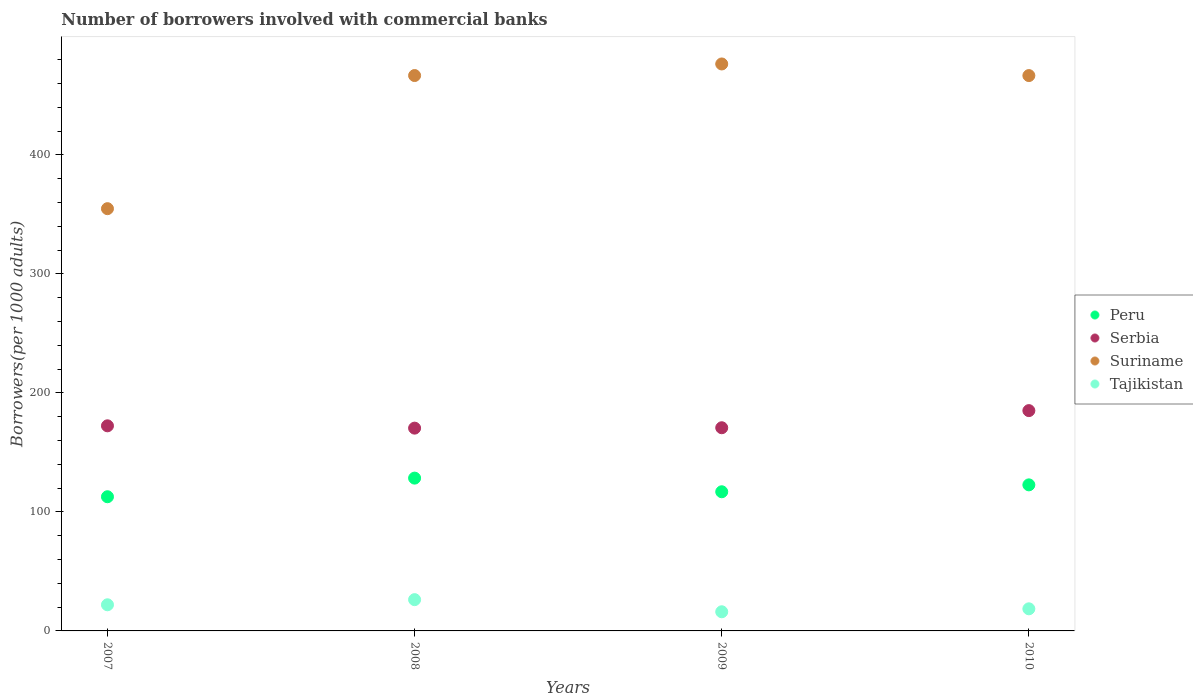What is the number of borrowers involved with commercial banks in Peru in 2008?
Give a very brief answer. 128.42. Across all years, what is the maximum number of borrowers involved with commercial banks in Serbia?
Ensure brevity in your answer.  185.15. Across all years, what is the minimum number of borrowers involved with commercial banks in Suriname?
Provide a succinct answer. 354.87. What is the total number of borrowers involved with commercial banks in Suriname in the graph?
Provide a succinct answer. 1764.83. What is the difference between the number of borrowers involved with commercial banks in Serbia in 2007 and that in 2010?
Ensure brevity in your answer.  -12.78. What is the difference between the number of borrowers involved with commercial banks in Serbia in 2009 and the number of borrowers involved with commercial banks in Tajikistan in 2010?
Provide a short and direct response. 152.17. What is the average number of borrowers involved with commercial banks in Serbia per year?
Offer a terse response. 174.68. In the year 2007, what is the difference between the number of borrowers involved with commercial banks in Peru and number of borrowers involved with commercial banks in Tajikistan?
Make the answer very short. 90.8. What is the ratio of the number of borrowers involved with commercial banks in Tajikistan in 2007 to that in 2009?
Provide a succinct answer. 1.37. What is the difference between the highest and the second highest number of borrowers involved with commercial banks in Suriname?
Give a very brief answer. 9.73. What is the difference between the highest and the lowest number of borrowers involved with commercial banks in Tajikistan?
Your response must be concise. 10.2. Is the number of borrowers involved with commercial banks in Suriname strictly greater than the number of borrowers involved with commercial banks in Peru over the years?
Offer a terse response. Yes. How many years are there in the graph?
Your answer should be very brief. 4. What is the difference between two consecutive major ticks on the Y-axis?
Make the answer very short. 100. Does the graph contain grids?
Give a very brief answer. No. Where does the legend appear in the graph?
Your answer should be compact. Center right. What is the title of the graph?
Offer a very short reply. Number of borrowers involved with commercial banks. What is the label or title of the X-axis?
Make the answer very short. Years. What is the label or title of the Y-axis?
Your answer should be very brief. Borrowers(per 1000 adults). What is the Borrowers(per 1000 adults) in Peru in 2007?
Your answer should be compact. 112.76. What is the Borrowers(per 1000 adults) in Serbia in 2007?
Provide a succinct answer. 172.37. What is the Borrowers(per 1000 adults) of Suriname in 2007?
Provide a short and direct response. 354.87. What is the Borrowers(per 1000 adults) in Tajikistan in 2007?
Offer a very short reply. 21.97. What is the Borrowers(per 1000 adults) of Peru in 2008?
Make the answer very short. 128.42. What is the Borrowers(per 1000 adults) of Serbia in 2008?
Provide a succinct answer. 170.42. What is the Borrowers(per 1000 adults) in Suriname in 2008?
Your answer should be compact. 466.75. What is the Borrowers(per 1000 adults) in Tajikistan in 2008?
Keep it short and to the point. 26.29. What is the Borrowers(per 1000 adults) of Peru in 2009?
Keep it short and to the point. 116.95. What is the Borrowers(per 1000 adults) in Serbia in 2009?
Offer a very short reply. 170.75. What is the Borrowers(per 1000 adults) of Suriname in 2009?
Offer a very short reply. 476.48. What is the Borrowers(per 1000 adults) in Tajikistan in 2009?
Ensure brevity in your answer.  16.09. What is the Borrowers(per 1000 adults) of Peru in 2010?
Your answer should be very brief. 122.75. What is the Borrowers(per 1000 adults) in Serbia in 2010?
Provide a succinct answer. 185.15. What is the Borrowers(per 1000 adults) in Suriname in 2010?
Offer a very short reply. 466.73. What is the Borrowers(per 1000 adults) of Tajikistan in 2010?
Offer a terse response. 18.58. Across all years, what is the maximum Borrowers(per 1000 adults) in Peru?
Make the answer very short. 128.42. Across all years, what is the maximum Borrowers(per 1000 adults) of Serbia?
Provide a short and direct response. 185.15. Across all years, what is the maximum Borrowers(per 1000 adults) in Suriname?
Ensure brevity in your answer.  476.48. Across all years, what is the maximum Borrowers(per 1000 adults) in Tajikistan?
Ensure brevity in your answer.  26.29. Across all years, what is the minimum Borrowers(per 1000 adults) in Peru?
Your answer should be compact. 112.76. Across all years, what is the minimum Borrowers(per 1000 adults) in Serbia?
Provide a short and direct response. 170.42. Across all years, what is the minimum Borrowers(per 1000 adults) in Suriname?
Your answer should be compact. 354.87. Across all years, what is the minimum Borrowers(per 1000 adults) of Tajikistan?
Give a very brief answer. 16.09. What is the total Borrowers(per 1000 adults) of Peru in the graph?
Make the answer very short. 480.89. What is the total Borrowers(per 1000 adults) in Serbia in the graph?
Ensure brevity in your answer.  698.7. What is the total Borrowers(per 1000 adults) of Suriname in the graph?
Offer a very short reply. 1764.83. What is the total Borrowers(per 1000 adults) of Tajikistan in the graph?
Keep it short and to the point. 82.92. What is the difference between the Borrowers(per 1000 adults) in Peru in 2007 and that in 2008?
Give a very brief answer. -15.66. What is the difference between the Borrowers(per 1000 adults) in Serbia in 2007 and that in 2008?
Make the answer very short. 1.95. What is the difference between the Borrowers(per 1000 adults) of Suriname in 2007 and that in 2008?
Provide a succinct answer. -111.88. What is the difference between the Borrowers(per 1000 adults) in Tajikistan in 2007 and that in 2008?
Your answer should be very brief. -4.32. What is the difference between the Borrowers(per 1000 adults) in Peru in 2007 and that in 2009?
Your answer should be compact. -4.19. What is the difference between the Borrowers(per 1000 adults) in Serbia in 2007 and that in 2009?
Offer a very short reply. 1.62. What is the difference between the Borrowers(per 1000 adults) in Suriname in 2007 and that in 2009?
Make the answer very short. -121.61. What is the difference between the Borrowers(per 1000 adults) of Tajikistan in 2007 and that in 2009?
Your response must be concise. 5.88. What is the difference between the Borrowers(per 1000 adults) of Peru in 2007 and that in 2010?
Ensure brevity in your answer.  -9.99. What is the difference between the Borrowers(per 1000 adults) of Serbia in 2007 and that in 2010?
Keep it short and to the point. -12.78. What is the difference between the Borrowers(per 1000 adults) of Suriname in 2007 and that in 2010?
Ensure brevity in your answer.  -111.86. What is the difference between the Borrowers(per 1000 adults) of Tajikistan in 2007 and that in 2010?
Give a very brief answer. 3.39. What is the difference between the Borrowers(per 1000 adults) in Peru in 2008 and that in 2009?
Ensure brevity in your answer.  11.47. What is the difference between the Borrowers(per 1000 adults) of Serbia in 2008 and that in 2009?
Ensure brevity in your answer.  -0.33. What is the difference between the Borrowers(per 1000 adults) of Suriname in 2008 and that in 2009?
Provide a short and direct response. -9.73. What is the difference between the Borrowers(per 1000 adults) in Tajikistan in 2008 and that in 2009?
Make the answer very short. 10.2. What is the difference between the Borrowers(per 1000 adults) of Peru in 2008 and that in 2010?
Offer a terse response. 5.67. What is the difference between the Borrowers(per 1000 adults) of Serbia in 2008 and that in 2010?
Provide a succinct answer. -14.73. What is the difference between the Borrowers(per 1000 adults) in Suriname in 2008 and that in 2010?
Offer a very short reply. 0.03. What is the difference between the Borrowers(per 1000 adults) of Tajikistan in 2008 and that in 2010?
Your response must be concise. 7.71. What is the difference between the Borrowers(per 1000 adults) of Peru in 2009 and that in 2010?
Make the answer very short. -5.8. What is the difference between the Borrowers(per 1000 adults) in Serbia in 2009 and that in 2010?
Ensure brevity in your answer.  -14.4. What is the difference between the Borrowers(per 1000 adults) in Suriname in 2009 and that in 2010?
Keep it short and to the point. 9.76. What is the difference between the Borrowers(per 1000 adults) in Tajikistan in 2009 and that in 2010?
Give a very brief answer. -2.49. What is the difference between the Borrowers(per 1000 adults) of Peru in 2007 and the Borrowers(per 1000 adults) of Serbia in 2008?
Your response must be concise. -57.66. What is the difference between the Borrowers(per 1000 adults) in Peru in 2007 and the Borrowers(per 1000 adults) in Suriname in 2008?
Your answer should be very brief. -353.99. What is the difference between the Borrowers(per 1000 adults) of Peru in 2007 and the Borrowers(per 1000 adults) of Tajikistan in 2008?
Offer a very short reply. 86.48. What is the difference between the Borrowers(per 1000 adults) of Serbia in 2007 and the Borrowers(per 1000 adults) of Suriname in 2008?
Provide a short and direct response. -294.38. What is the difference between the Borrowers(per 1000 adults) in Serbia in 2007 and the Borrowers(per 1000 adults) in Tajikistan in 2008?
Make the answer very short. 146.09. What is the difference between the Borrowers(per 1000 adults) of Suriname in 2007 and the Borrowers(per 1000 adults) of Tajikistan in 2008?
Your answer should be compact. 328.58. What is the difference between the Borrowers(per 1000 adults) in Peru in 2007 and the Borrowers(per 1000 adults) in Serbia in 2009?
Give a very brief answer. -57.99. What is the difference between the Borrowers(per 1000 adults) in Peru in 2007 and the Borrowers(per 1000 adults) in Suriname in 2009?
Your response must be concise. -363.72. What is the difference between the Borrowers(per 1000 adults) of Peru in 2007 and the Borrowers(per 1000 adults) of Tajikistan in 2009?
Your answer should be compact. 96.67. What is the difference between the Borrowers(per 1000 adults) of Serbia in 2007 and the Borrowers(per 1000 adults) of Suriname in 2009?
Your response must be concise. -304.11. What is the difference between the Borrowers(per 1000 adults) of Serbia in 2007 and the Borrowers(per 1000 adults) of Tajikistan in 2009?
Offer a terse response. 156.28. What is the difference between the Borrowers(per 1000 adults) in Suriname in 2007 and the Borrowers(per 1000 adults) in Tajikistan in 2009?
Give a very brief answer. 338.78. What is the difference between the Borrowers(per 1000 adults) of Peru in 2007 and the Borrowers(per 1000 adults) of Serbia in 2010?
Give a very brief answer. -72.39. What is the difference between the Borrowers(per 1000 adults) in Peru in 2007 and the Borrowers(per 1000 adults) in Suriname in 2010?
Ensure brevity in your answer.  -353.96. What is the difference between the Borrowers(per 1000 adults) of Peru in 2007 and the Borrowers(per 1000 adults) of Tajikistan in 2010?
Provide a short and direct response. 94.18. What is the difference between the Borrowers(per 1000 adults) of Serbia in 2007 and the Borrowers(per 1000 adults) of Suriname in 2010?
Provide a short and direct response. -294.35. What is the difference between the Borrowers(per 1000 adults) of Serbia in 2007 and the Borrowers(per 1000 adults) of Tajikistan in 2010?
Provide a short and direct response. 153.79. What is the difference between the Borrowers(per 1000 adults) of Suriname in 2007 and the Borrowers(per 1000 adults) of Tajikistan in 2010?
Your answer should be very brief. 336.29. What is the difference between the Borrowers(per 1000 adults) of Peru in 2008 and the Borrowers(per 1000 adults) of Serbia in 2009?
Keep it short and to the point. -42.33. What is the difference between the Borrowers(per 1000 adults) in Peru in 2008 and the Borrowers(per 1000 adults) in Suriname in 2009?
Your answer should be compact. -348.06. What is the difference between the Borrowers(per 1000 adults) in Peru in 2008 and the Borrowers(per 1000 adults) in Tajikistan in 2009?
Your answer should be compact. 112.33. What is the difference between the Borrowers(per 1000 adults) in Serbia in 2008 and the Borrowers(per 1000 adults) in Suriname in 2009?
Your response must be concise. -306.06. What is the difference between the Borrowers(per 1000 adults) in Serbia in 2008 and the Borrowers(per 1000 adults) in Tajikistan in 2009?
Your answer should be compact. 154.33. What is the difference between the Borrowers(per 1000 adults) in Suriname in 2008 and the Borrowers(per 1000 adults) in Tajikistan in 2009?
Keep it short and to the point. 450.66. What is the difference between the Borrowers(per 1000 adults) in Peru in 2008 and the Borrowers(per 1000 adults) in Serbia in 2010?
Your answer should be very brief. -56.73. What is the difference between the Borrowers(per 1000 adults) in Peru in 2008 and the Borrowers(per 1000 adults) in Suriname in 2010?
Provide a succinct answer. -338.3. What is the difference between the Borrowers(per 1000 adults) in Peru in 2008 and the Borrowers(per 1000 adults) in Tajikistan in 2010?
Your answer should be compact. 109.84. What is the difference between the Borrowers(per 1000 adults) in Serbia in 2008 and the Borrowers(per 1000 adults) in Suriname in 2010?
Offer a very short reply. -296.3. What is the difference between the Borrowers(per 1000 adults) of Serbia in 2008 and the Borrowers(per 1000 adults) of Tajikistan in 2010?
Make the answer very short. 151.84. What is the difference between the Borrowers(per 1000 adults) in Suriname in 2008 and the Borrowers(per 1000 adults) in Tajikistan in 2010?
Provide a short and direct response. 448.17. What is the difference between the Borrowers(per 1000 adults) of Peru in 2009 and the Borrowers(per 1000 adults) of Serbia in 2010?
Offer a very short reply. -68.2. What is the difference between the Borrowers(per 1000 adults) of Peru in 2009 and the Borrowers(per 1000 adults) of Suriname in 2010?
Make the answer very short. -349.77. What is the difference between the Borrowers(per 1000 adults) of Peru in 2009 and the Borrowers(per 1000 adults) of Tajikistan in 2010?
Keep it short and to the point. 98.37. What is the difference between the Borrowers(per 1000 adults) in Serbia in 2009 and the Borrowers(per 1000 adults) in Suriname in 2010?
Ensure brevity in your answer.  -295.97. What is the difference between the Borrowers(per 1000 adults) of Serbia in 2009 and the Borrowers(per 1000 adults) of Tajikistan in 2010?
Provide a short and direct response. 152.17. What is the difference between the Borrowers(per 1000 adults) of Suriname in 2009 and the Borrowers(per 1000 adults) of Tajikistan in 2010?
Ensure brevity in your answer.  457.9. What is the average Borrowers(per 1000 adults) in Peru per year?
Your answer should be compact. 120.22. What is the average Borrowers(per 1000 adults) in Serbia per year?
Make the answer very short. 174.68. What is the average Borrowers(per 1000 adults) of Suriname per year?
Keep it short and to the point. 441.21. What is the average Borrowers(per 1000 adults) in Tajikistan per year?
Keep it short and to the point. 20.73. In the year 2007, what is the difference between the Borrowers(per 1000 adults) in Peru and Borrowers(per 1000 adults) in Serbia?
Make the answer very short. -59.61. In the year 2007, what is the difference between the Borrowers(per 1000 adults) of Peru and Borrowers(per 1000 adults) of Suriname?
Provide a short and direct response. -242.11. In the year 2007, what is the difference between the Borrowers(per 1000 adults) of Peru and Borrowers(per 1000 adults) of Tajikistan?
Give a very brief answer. 90.8. In the year 2007, what is the difference between the Borrowers(per 1000 adults) in Serbia and Borrowers(per 1000 adults) in Suriname?
Offer a very short reply. -182.5. In the year 2007, what is the difference between the Borrowers(per 1000 adults) of Serbia and Borrowers(per 1000 adults) of Tajikistan?
Your response must be concise. 150.4. In the year 2007, what is the difference between the Borrowers(per 1000 adults) in Suriname and Borrowers(per 1000 adults) in Tajikistan?
Keep it short and to the point. 332.9. In the year 2008, what is the difference between the Borrowers(per 1000 adults) in Peru and Borrowers(per 1000 adults) in Serbia?
Your response must be concise. -42. In the year 2008, what is the difference between the Borrowers(per 1000 adults) in Peru and Borrowers(per 1000 adults) in Suriname?
Provide a short and direct response. -338.33. In the year 2008, what is the difference between the Borrowers(per 1000 adults) in Peru and Borrowers(per 1000 adults) in Tajikistan?
Ensure brevity in your answer.  102.13. In the year 2008, what is the difference between the Borrowers(per 1000 adults) in Serbia and Borrowers(per 1000 adults) in Suriname?
Ensure brevity in your answer.  -296.33. In the year 2008, what is the difference between the Borrowers(per 1000 adults) in Serbia and Borrowers(per 1000 adults) in Tajikistan?
Offer a terse response. 144.14. In the year 2008, what is the difference between the Borrowers(per 1000 adults) in Suriname and Borrowers(per 1000 adults) in Tajikistan?
Provide a succinct answer. 440.47. In the year 2009, what is the difference between the Borrowers(per 1000 adults) of Peru and Borrowers(per 1000 adults) of Serbia?
Provide a short and direct response. -53.8. In the year 2009, what is the difference between the Borrowers(per 1000 adults) in Peru and Borrowers(per 1000 adults) in Suriname?
Give a very brief answer. -359.53. In the year 2009, what is the difference between the Borrowers(per 1000 adults) in Peru and Borrowers(per 1000 adults) in Tajikistan?
Give a very brief answer. 100.86. In the year 2009, what is the difference between the Borrowers(per 1000 adults) in Serbia and Borrowers(per 1000 adults) in Suriname?
Your answer should be compact. -305.73. In the year 2009, what is the difference between the Borrowers(per 1000 adults) in Serbia and Borrowers(per 1000 adults) in Tajikistan?
Your response must be concise. 154.66. In the year 2009, what is the difference between the Borrowers(per 1000 adults) of Suriname and Borrowers(per 1000 adults) of Tajikistan?
Ensure brevity in your answer.  460.39. In the year 2010, what is the difference between the Borrowers(per 1000 adults) in Peru and Borrowers(per 1000 adults) in Serbia?
Give a very brief answer. -62.4. In the year 2010, what is the difference between the Borrowers(per 1000 adults) in Peru and Borrowers(per 1000 adults) in Suriname?
Your answer should be compact. -343.97. In the year 2010, what is the difference between the Borrowers(per 1000 adults) in Peru and Borrowers(per 1000 adults) in Tajikistan?
Your response must be concise. 104.17. In the year 2010, what is the difference between the Borrowers(per 1000 adults) in Serbia and Borrowers(per 1000 adults) in Suriname?
Your response must be concise. -281.57. In the year 2010, what is the difference between the Borrowers(per 1000 adults) in Serbia and Borrowers(per 1000 adults) in Tajikistan?
Make the answer very short. 166.57. In the year 2010, what is the difference between the Borrowers(per 1000 adults) of Suriname and Borrowers(per 1000 adults) of Tajikistan?
Your answer should be very brief. 448.15. What is the ratio of the Borrowers(per 1000 adults) in Peru in 2007 to that in 2008?
Give a very brief answer. 0.88. What is the ratio of the Borrowers(per 1000 adults) in Serbia in 2007 to that in 2008?
Your answer should be very brief. 1.01. What is the ratio of the Borrowers(per 1000 adults) in Suriname in 2007 to that in 2008?
Offer a very short reply. 0.76. What is the ratio of the Borrowers(per 1000 adults) in Tajikistan in 2007 to that in 2008?
Ensure brevity in your answer.  0.84. What is the ratio of the Borrowers(per 1000 adults) in Peru in 2007 to that in 2009?
Provide a succinct answer. 0.96. What is the ratio of the Borrowers(per 1000 adults) in Serbia in 2007 to that in 2009?
Make the answer very short. 1.01. What is the ratio of the Borrowers(per 1000 adults) in Suriname in 2007 to that in 2009?
Your answer should be compact. 0.74. What is the ratio of the Borrowers(per 1000 adults) of Tajikistan in 2007 to that in 2009?
Ensure brevity in your answer.  1.37. What is the ratio of the Borrowers(per 1000 adults) of Peru in 2007 to that in 2010?
Keep it short and to the point. 0.92. What is the ratio of the Borrowers(per 1000 adults) of Suriname in 2007 to that in 2010?
Your answer should be compact. 0.76. What is the ratio of the Borrowers(per 1000 adults) in Tajikistan in 2007 to that in 2010?
Make the answer very short. 1.18. What is the ratio of the Borrowers(per 1000 adults) of Peru in 2008 to that in 2009?
Ensure brevity in your answer.  1.1. What is the ratio of the Borrowers(per 1000 adults) of Serbia in 2008 to that in 2009?
Your response must be concise. 1. What is the ratio of the Borrowers(per 1000 adults) of Suriname in 2008 to that in 2009?
Your response must be concise. 0.98. What is the ratio of the Borrowers(per 1000 adults) in Tajikistan in 2008 to that in 2009?
Offer a very short reply. 1.63. What is the ratio of the Borrowers(per 1000 adults) of Peru in 2008 to that in 2010?
Your response must be concise. 1.05. What is the ratio of the Borrowers(per 1000 adults) of Serbia in 2008 to that in 2010?
Keep it short and to the point. 0.92. What is the ratio of the Borrowers(per 1000 adults) of Tajikistan in 2008 to that in 2010?
Offer a terse response. 1.41. What is the ratio of the Borrowers(per 1000 adults) of Peru in 2009 to that in 2010?
Your answer should be very brief. 0.95. What is the ratio of the Borrowers(per 1000 adults) of Serbia in 2009 to that in 2010?
Your answer should be very brief. 0.92. What is the ratio of the Borrowers(per 1000 adults) of Suriname in 2009 to that in 2010?
Ensure brevity in your answer.  1.02. What is the ratio of the Borrowers(per 1000 adults) of Tajikistan in 2009 to that in 2010?
Provide a succinct answer. 0.87. What is the difference between the highest and the second highest Borrowers(per 1000 adults) in Peru?
Your answer should be very brief. 5.67. What is the difference between the highest and the second highest Borrowers(per 1000 adults) in Serbia?
Your answer should be very brief. 12.78. What is the difference between the highest and the second highest Borrowers(per 1000 adults) of Suriname?
Provide a short and direct response. 9.73. What is the difference between the highest and the second highest Borrowers(per 1000 adults) of Tajikistan?
Your answer should be very brief. 4.32. What is the difference between the highest and the lowest Borrowers(per 1000 adults) in Peru?
Your answer should be compact. 15.66. What is the difference between the highest and the lowest Borrowers(per 1000 adults) of Serbia?
Ensure brevity in your answer.  14.73. What is the difference between the highest and the lowest Borrowers(per 1000 adults) in Suriname?
Make the answer very short. 121.61. What is the difference between the highest and the lowest Borrowers(per 1000 adults) of Tajikistan?
Ensure brevity in your answer.  10.2. 